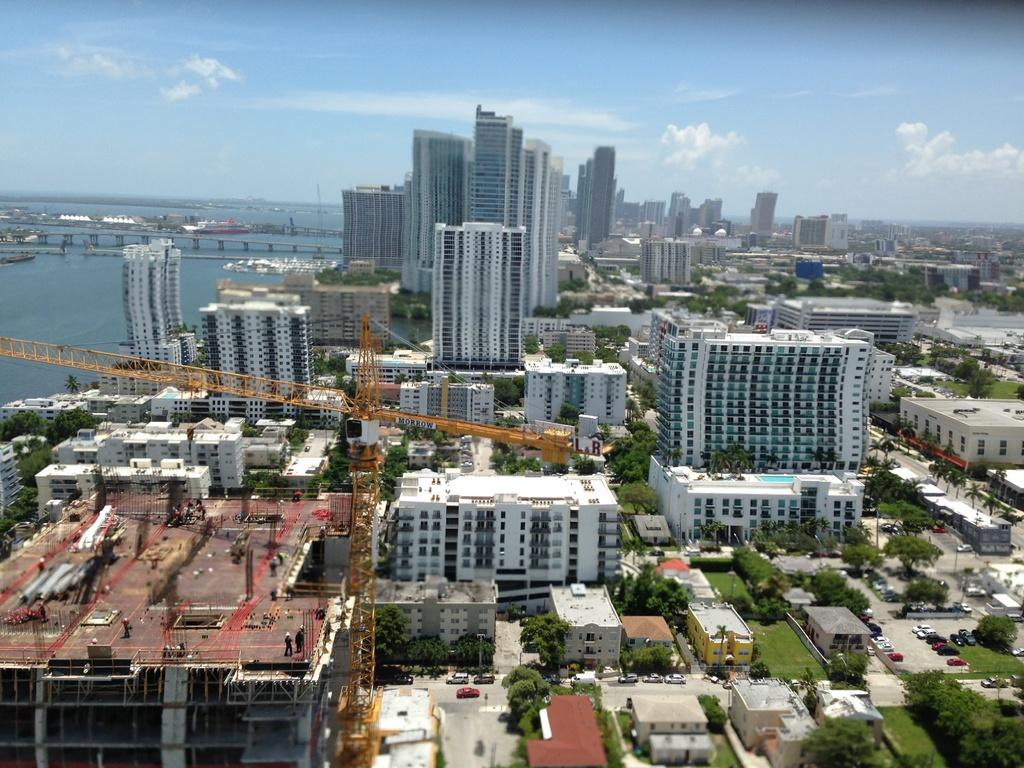What type of structures can be seen in the image? There are buildings in the image. What piece of construction equipment is present in the image? There is a crane in the image. What type of vegetation is visible in the image? There are trees and grass in the image. What type of transportation can be seen in the image? There are vehicles in the image. What natural feature is visible in the background of the image? The background of the image includes water and a bridge. What part of the natural environment is visible in the image? The sky is visible in the background of the image. What type of calculator is being used by the coach in the image? There is no calculator or coach present in the image. How many cars are visible in the image? There is no specific mention of cars in the image, only vehicles in general. 